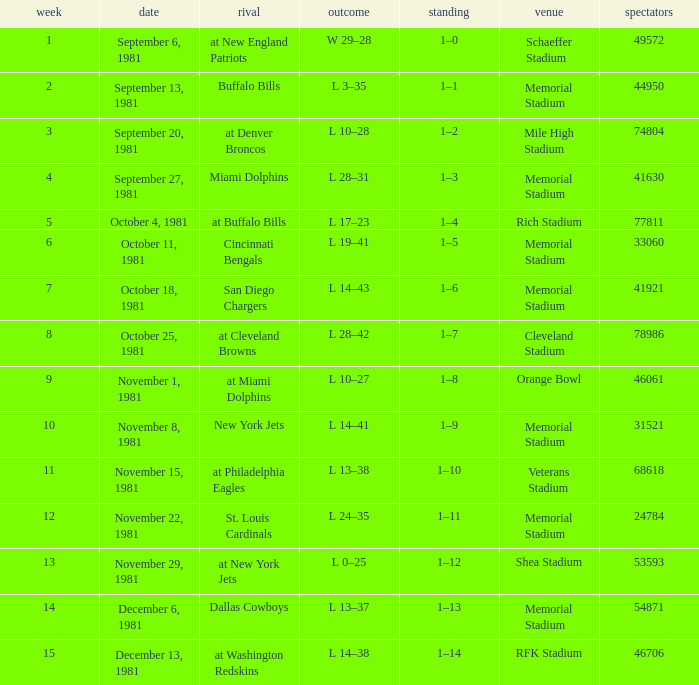When it is week 2 what is the record? 1–1. Parse the table in full. {'header': ['week', 'date', 'rival', 'outcome', 'standing', 'venue', 'spectators'], 'rows': [['1', 'September 6, 1981', 'at New England Patriots', 'W 29–28', '1–0', 'Schaeffer Stadium', '49572'], ['2', 'September 13, 1981', 'Buffalo Bills', 'L 3–35', '1–1', 'Memorial Stadium', '44950'], ['3', 'September 20, 1981', 'at Denver Broncos', 'L 10–28', '1–2', 'Mile High Stadium', '74804'], ['4', 'September 27, 1981', 'Miami Dolphins', 'L 28–31', '1–3', 'Memorial Stadium', '41630'], ['5', 'October 4, 1981', 'at Buffalo Bills', 'L 17–23', '1–4', 'Rich Stadium', '77811'], ['6', 'October 11, 1981', 'Cincinnati Bengals', 'L 19–41', '1–5', 'Memorial Stadium', '33060'], ['7', 'October 18, 1981', 'San Diego Chargers', 'L 14–43', '1–6', 'Memorial Stadium', '41921'], ['8', 'October 25, 1981', 'at Cleveland Browns', 'L 28–42', '1–7', 'Cleveland Stadium', '78986'], ['9', 'November 1, 1981', 'at Miami Dolphins', 'L 10–27', '1–8', 'Orange Bowl', '46061'], ['10', 'November 8, 1981', 'New York Jets', 'L 14–41', '1–9', 'Memorial Stadium', '31521'], ['11', 'November 15, 1981', 'at Philadelphia Eagles', 'L 13–38', '1–10', 'Veterans Stadium', '68618'], ['12', 'November 22, 1981', 'St. Louis Cardinals', 'L 24–35', '1–11', 'Memorial Stadium', '24784'], ['13', 'November 29, 1981', 'at New York Jets', 'L 0–25', '1–12', 'Shea Stadium', '53593'], ['14', 'December 6, 1981', 'Dallas Cowboys', 'L 13–37', '1–13', 'Memorial Stadium', '54871'], ['15', 'December 13, 1981', 'at Washington Redskins', 'L 14–38', '1–14', 'RFK Stadium', '46706']]} 